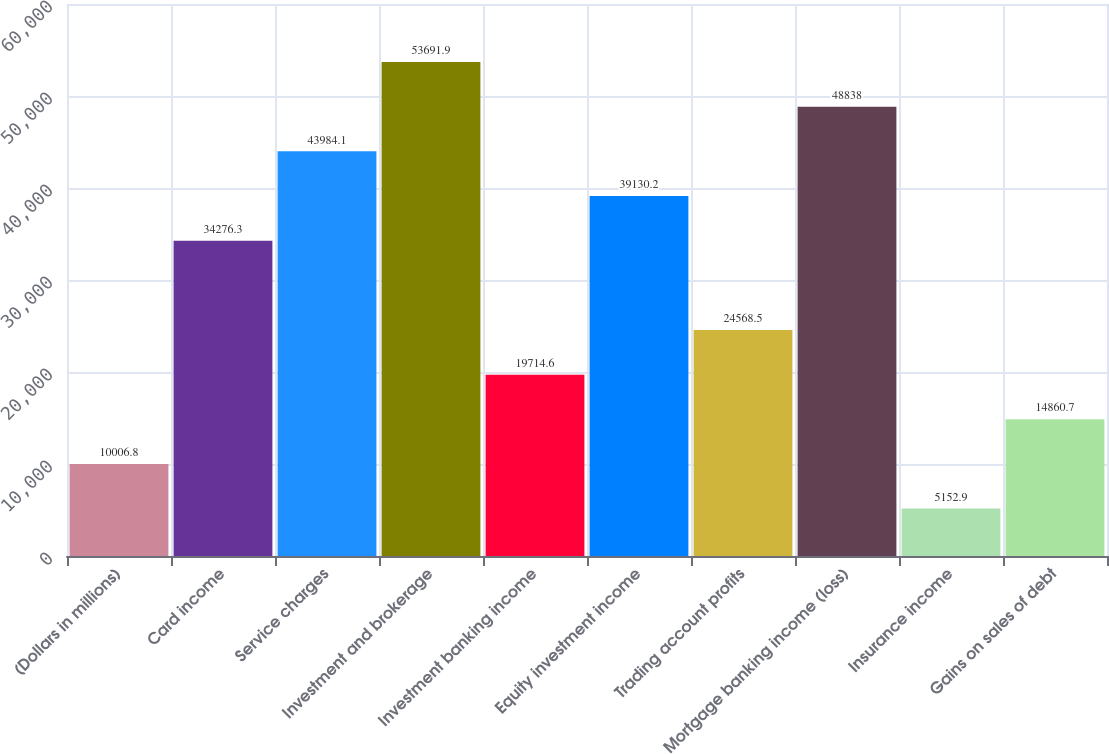Convert chart. <chart><loc_0><loc_0><loc_500><loc_500><bar_chart><fcel>(Dollars in millions)<fcel>Card income<fcel>Service charges<fcel>Investment and brokerage<fcel>Investment banking income<fcel>Equity investment income<fcel>Trading account profits<fcel>Mortgage banking income (loss)<fcel>Insurance income<fcel>Gains on sales of debt<nl><fcel>10006.8<fcel>34276.3<fcel>43984.1<fcel>53691.9<fcel>19714.6<fcel>39130.2<fcel>24568.5<fcel>48838<fcel>5152.9<fcel>14860.7<nl></chart> 